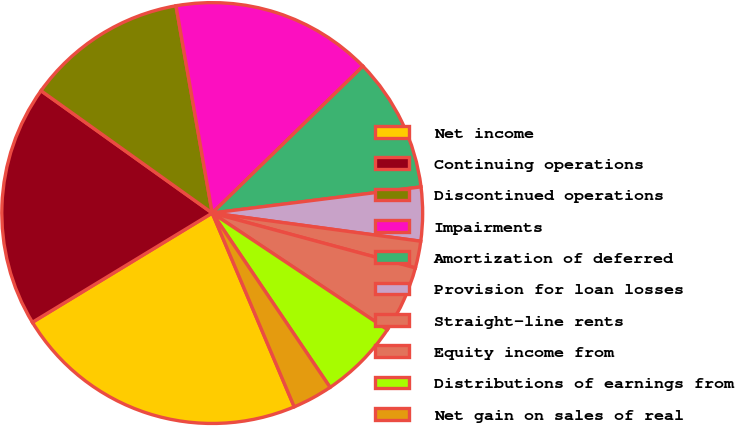Convert chart to OTSL. <chart><loc_0><loc_0><loc_500><loc_500><pie_chart><fcel>Net income<fcel>Continuing operations<fcel>Discontinued operations<fcel>Impairments<fcel>Amortization of deferred<fcel>Provision for loan losses<fcel>Straight-line rents<fcel>Equity income from<fcel>Distributions of earnings from<fcel>Net gain on sales of real<nl><fcel>22.68%<fcel>18.56%<fcel>12.37%<fcel>15.46%<fcel>10.31%<fcel>4.12%<fcel>2.06%<fcel>5.15%<fcel>6.19%<fcel>3.09%<nl></chart> 